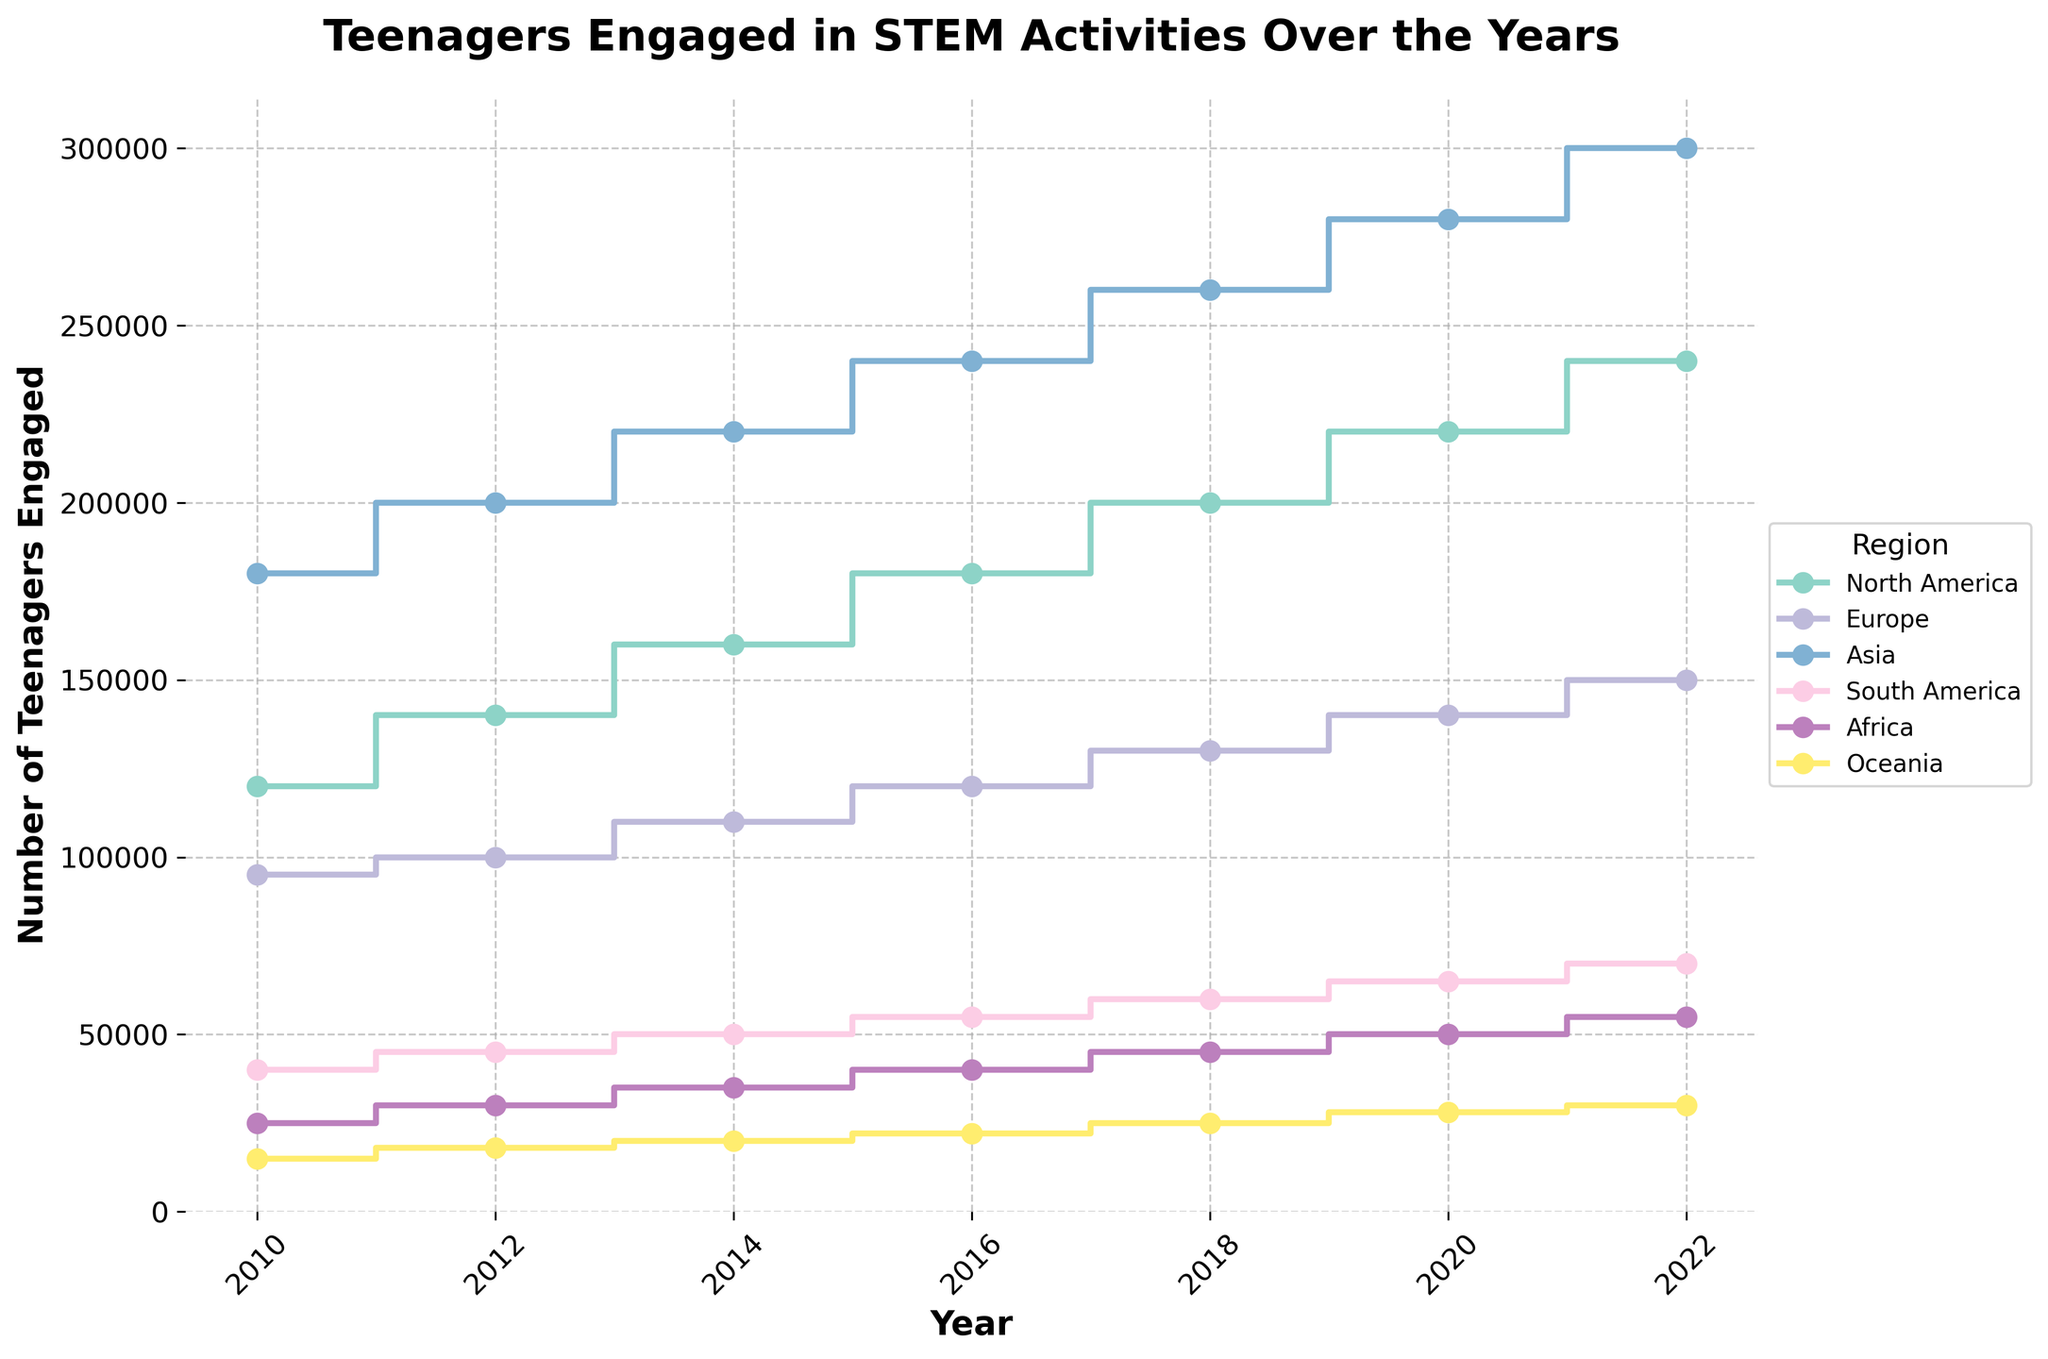What is the title of the figure? The title of the figure is indicated at the top of the plot. The title is prominently displayed in bold font.
Answer: Teenagers Engaged in STEM Activities Over the Years How many regions are represented in the figure? The figure's legend displays all regions represented in the data. Count the distinct regions listed in the legend.
Answer: 6 Which region had the highest number of teenagers engaged in 2020? Look at the intersection of the lines corresponding to the year 2020 on the x-axis and identify the region with the highest value on the y-axis.
Answer: Asia By how much did the number of teenagers engaged in STEM activities increase in North America from 2010 to 2022? Find the data points for North America in the years 2010 and 2022 on the plot. Subtract the 2010 value from the 2022 value.
Answer: 120000 What is the smallest number of teenagers engaged in STEM activities in any region for the year 2010? Locate the data points for the year 2010 and find the minimum value on the y-axis among the regions.
Answer: 15000 Which region shows a consistent increase in the number of teenagers engaged in STEM activities from 2010 to 2022? Trace the steps for each region and determine which one shows an upward trend in every step without any decline.
Answer: Asia What is the average number of teenagers engaged in STEM activities in Oceania across all the years? Identify the data points for Oceania, sum them, and then divide by the total number of years.
Answer: 21333.33 How much more teenagers were engaged in STEM activities in Europe compared to South America in 2014? Locate the data points for Europe and South America in 2014 and subtract the value for South America from the value for Europe.
Answer: 60000 In which year did Africa see the largest increase in teenagers engaged in STEM activities compared to the previous recorded year? Examine the differences in the number of teenagers engaged between consecutive years for Africa and identify the largest increase.
Answer: 2016 (5000 increase from 2014 to 2016) Did the number of teenagers engaged in STEM activities ever decrease for any region? If yes, which one? Trace the steps for each region and identify if any of the lines have a step-down indicating a decrease.
Answer: No 